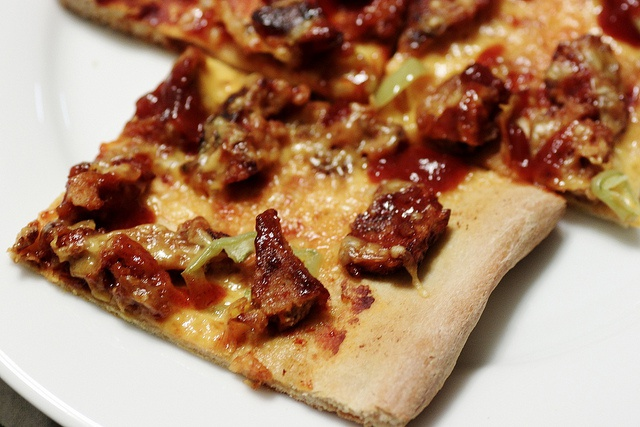Describe the objects in this image and their specific colors. I can see a pizza in lightgray, maroon, brown, tan, and black tones in this image. 